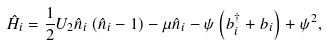Convert formula to latex. <formula><loc_0><loc_0><loc_500><loc_500>\hat { H } _ { i } = \frac { 1 } { 2 } U _ { 2 } \hat { n } _ { i } \left ( \hat { n } _ { i } - 1 \right ) - \mu \hat { n } _ { i } - \psi \left ( b ^ { \dag } _ { i } + b _ { i } \right ) + \psi ^ { 2 } ,</formula> 